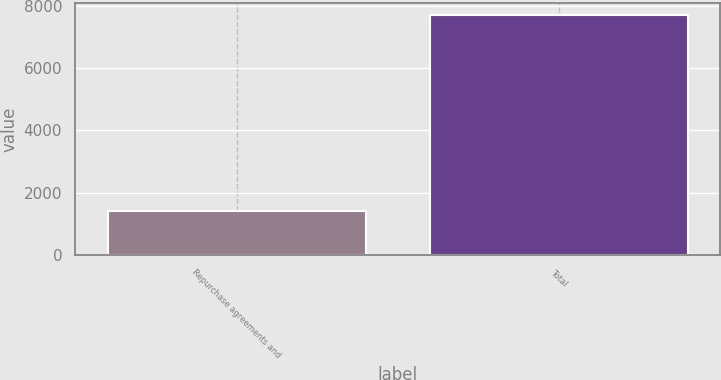Convert chart to OTSL. <chart><loc_0><loc_0><loc_500><loc_500><bar_chart><fcel>Repurchase agreements and<fcel>Total<nl><fcel>1405<fcel>7694<nl></chart> 